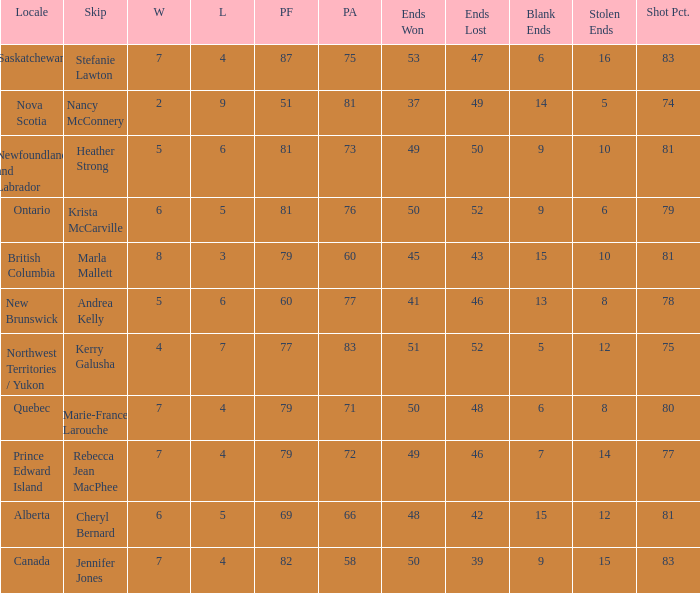What is the total of blank ends at Prince Edward Island? 7.0. 